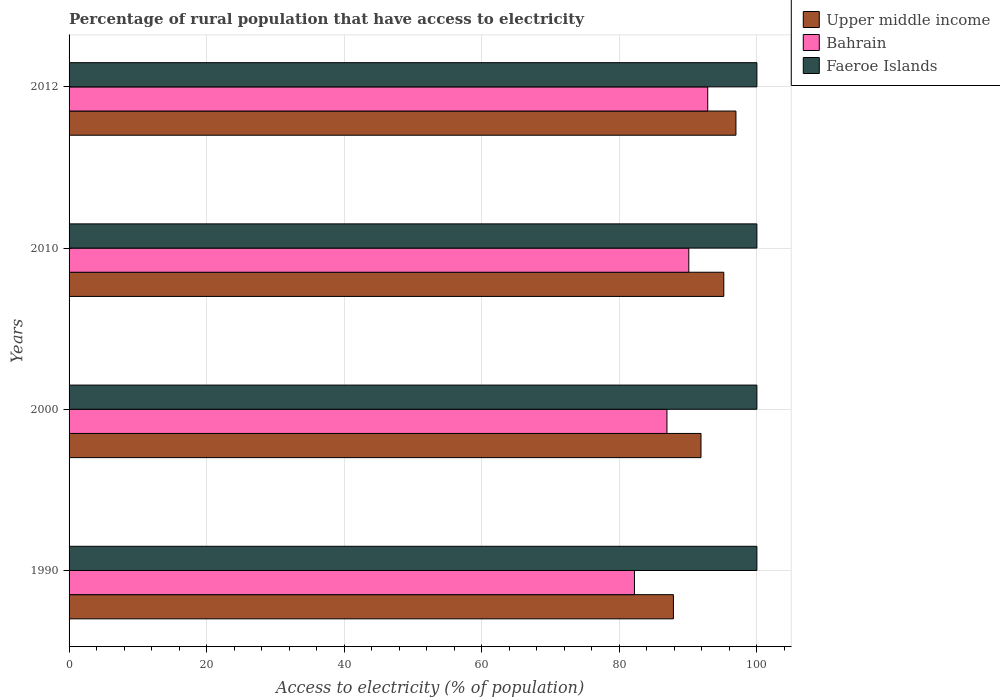How many groups of bars are there?
Your response must be concise. 4. How many bars are there on the 1st tick from the top?
Give a very brief answer. 3. How many bars are there on the 4th tick from the bottom?
Your answer should be very brief. 3. What is the label of the 2nd group of bars from the top?
Your response must be concise. 2010. In how many cases, is the number of bars for a given year not equal to the number of legend labels?
Offer a very short reply. 0. What is the percentage of rural population that have access to electricity in Faeroe Islands in 1990?
Give a very brief answer. 100. Across all years, what is the maximum percentage of rural population that have access to electricity in Upper middle income?
Offer a terse response. 96.95. Across all years, what is the minimum percentage of rural population that have access to electricity in Faeroe Islands?
Your response must be concise. 100. In which year was the percentage of rural population that have access to electricity in Faeroe Islands maximum?
Ensure brevity in your answer.  1990. In which year was the percentage of rural population that have access to electricity in Upper middle income minimum?
Give a very brief answer. 1990. What is the total percentage of rural population that have access to electricity in Upper middle income in the graph?
Give a very brief answer. 371.89. What is the difference between the percentage of rural population that have access to electricity in Faeroe Islands in 2010 and that in 2012?
Provide a succinct answer. 0. What is the difference between the percentage of rural population that have access to electricity in Faeroe Islands in 2010 and the percentage of rural population that have access to electricity in Upper middle income in 2012?
Give a very brief answer. 3.05. What is the average percentage of rural population that have access to electricity in Upper middle income per year?
Provide a short and direct response. 92.97. In the year 2010, what is the difference between the percentage of rural population that have access to electricity in Faeroe Islands and percentage of rural population that have access to electricity in Upper middle income?
Your response must be concise. 4.81. In how many years, is the percentage of rural population that have access to electricity in Upper middle income greater than 76 %?
Ensure brevity in your answer.  4. What is the ratio of the percentage of rural population that have access to electricity in Faeroe Islands in 2000 to that in 2012?
Your answer should be very brief. 1. Is the difference between the percentage of rural population that have access to electricity in Faeroe Islands in 2000 and 2010 greater than the difference between the percentage of rural population that have access to electricity in Upper middle income in 2000 and 2010?
Ensure brevity in your answer.  Yes. What is the difference between the highest and the second highest percentage of rural population that have access to electricity in Bahrain?
Ensure brevity in your answer.  2.75. What is the difference between the highest and the lowest percentage of rural population that have access to electricity in Upper middle income?
Give a very brief answer. 9.09. What does the 1st bar from the top in 2012 represents?
Provide a short and direct response. Faeroe Islands. What does the 1st bar from the bottom in 2012 represents?
Provide a short and direct response. Upper middle income. Is it the case that in every year, the sum of the percentage of rural population that have access to electricity in Upper middle income and percentage of rural population that have access to electricity in Bahrain is greater than the percentage of rural population that have access to electricity in Faeroe Islands?
Your answer should be compact. Yes. What is the difference between two consecutive major ticks on the X-axis?
Offer a terse response. 20. How are the legend labels stacked?
Provide a short and direct response. Vertical. What is the title of the graph?
Offer a very short reply. Percentage of rural population that have access to electricity. Does "Libya" appear as one of the legend labels in the graph?
Your answer should be very brief. No. What is the label or title of the X-axis?
Your response must be concise. Access to electricity (% of population). What is the label or title of the Y-axis?
Provide a succinct answer. Years. What is the Access to electricity (% of population) of Upper middle income in 1990?
Provide a short and direct response. 87.87. What is the Access to electricity (% of population) of Bahrain in 1990?
Offer a terse response. 82.2. What is the Access to electricity (% of population) in Faeroe Islands in 1990?
Your answer should be very brief. 100. What is the Access to electricity (% of population) of Upper middle income in 2000?
Your response must be concise. 91.87. What is the Access to electricity (% of population) of Bahrain in 2000?
Your response must be concise. 86.93. What is the Access to electricity (% of population) of Upper middle income in 2010?
Your answer should be very brief. 95.19. What is the Access to electricity (% of population) of Bahrain in 2010?
Keep it short and to the point. 90.1. What is the Access to electricity (% of population) in Faeroe Islands in 2010?
Ensure brevity in your answer.  100. What is the Access to electricity (% of population) in Upper middle income in 2012?
Your answer should be compact. 96.95. What is the Access to electricity (% of population) of Bahrain in 2012?
Provide a succinct answer. 92.85. What is the Access to electricity (% of population) of Faeroe Islands in 2012?
Your answer should be compact. 100. Across all years, what is the maximum Access to electricity (% of population) of Upper middle income?
Provide a short and direct response. 96.95. Across all years, what is the maximum Access to electricity (% of population) of Bahrain?
Provide a short and direct response. 92.85. Across all years, what is the maximum Access to electricity (% of population) in Faeroe Islands?
Ensure brevity in your answer.  100. Across all years, what is the minimum Access to electricity (% of population) of Upper middle income?
Give a very brief answer. 87.87. Across all years, what is the minimum Access to electricity (% of population) in Bahrain?
Offer a terse response. 82.2. What is the total Access to electricity (% of population) of Upper middle income in the graph?
Give a very brief answer. 371.89. What is the total Access to electricity (% of population) in Bahrain in the graph?
Your answer should be very brief. 352.08. What is the difference between the Access to electricity (% of population) in Upper middle income in 1990 and that in 2000?
Keep it short and to the point. -4.01. What is the difference between the Access to electricity (% of population) of Bahrain in 1990 and that in 2000?
Give a very brief answer. -4.72. What is the difference between the Access to electricity (% of population) of Faeroe Islands in 1990 and that in 2000?
Keep it short and to the point. 0. What is the difference between the Access to electricity (% of population) in Upper middle income in 1990 and that in 2010?
Give a very brief answer. -7.32. What is the difference between the Access to electricity (% of population) of Bahrain in 1990 and that in 2010?
Give a very brief answer. -7.9. What is the difference between the Access to electricity (% of population) of Faeroe Islands in 1990 and that in 2010?
Offer a terse response. 0. What is the difference between the Access to electricity (% of population) in Upper middle income in 1990 and that in 2012?
Ensure brevity in your answer.  -9.09. What is the difference between the Access to electricity (% of population) of Bahrain in 1990 and that in 2012?
Ensure brevity in your answer.  -10.65. What is the difference between the Access to electricity (% of population) in Faeroe Islands in 1990 and that in 2012?
Give a very brief answer. 0. What is the difference between the Access to electricity (% of population) of Upper middle income in 2000 and that in 2010?
Offer a very short reply. -3.32. What is the difference between the Access to electricity (% of population) in Bahrain in 2000 and that in 2010?
Offer a terse response. -3.17. What is the difference between the Access to electricity (% of population) of Upper middle income in 2000 and that in 2012?
Ensure brevity in your answer.  -5.08. What is the difference between the Access to electricity (% of population) in Bahrain in 2000 and that in 2012?
Ensure brevity in your answer.  -5.93. What is the difference between the Access to electricity (% of population) of Faeroe Islands in 2000 and that in 2012?
Your answer should be very brief. 0. What is the difference between the Access to electricity (% of population) in Upper middle income in 2010 and that in 2012?
Provide a short and direct response. -1.76. What is the difference between the Access to electricity (% of population) of Bahrain in 2010 and that in 2012?
Offer a very short reply. -2.75. What is the difference between the Access to electricity (% of population) in Faeroe Islands in 2010 and that in 2012?
Keep it short and to the point. 0. What is the difference between the Access to electricity (% of population) in Upper middle income in 1990 and the Access to electricity (% of population) in Bahrain in 2000?
Your answer should be very brief. 0.94. What is the difference between the Access to electricity (% of population) of Upper middle income in 1990 and the Access to electricity (% of population) of Faeroe Islands in 2000?
Make the answer very short. -12.13. What is the difference between the Access to electricity (% of population) in Bahrain in 1990 and the Access to electricity (% of population) in Faeroe Islands in 2000?
Provide a short and direct response. -17.8. What is the difference between the Access to electricity (% of population) of Upper middle income in 1990 and the Access to electricity (% of population) of Bahrain in 2010?
Offer a very short reply. -2.23. What is the difference between the Access to electricity (% of population) of Upper middle income in 1990 and the Access to electricity (% of population) of Faeroe Islands in 2010?
Your answer should be compact. -12.13. What is the difference between the Access to electricity (% of population) in Bahrain in 1990 and the Access to electricity (% of population) in Faeroe Islands in 2010?
Your answer should be very brief. -17.8. What is the difference between the Access to electricity (% of population) of Upper middle income in 1990 and the Access to electricity (% of population) of Bahrain in 2012?
Provide a succinct answer. -4.99. What is the difference between the Access to electricity (% of population) in Upper middle income in 1990 and the Access to electricity (% of population) in Faeroe Islands in 2012?
Offer a very short reply. -12.13. What is the difference between the Access to electricity (% of population) in Bahrain in 1990 and the Access to electricity (% of population) in Faeroe Islands in 2012?
Your answer should be very brief. -17.8. What is the difference between the Access to electricity (% of population) in Upper middle income in 2000 and the Access to electricity (% of population) in Bahrain in 2010?
Keep it short and to the point. 1.77. What is the difference between the Access to electricity (% of population) in Upper middle income in 2000 and the Access to electricity (% of population) in Faeroe Islands in 2010?
Your response must be concise. -8.13. What is the difference between the Access to electricity (% of population) of Bahrain in 2000 and the Access to electricity (% of population) of Faeroe Islands in 2010?
Keep it short and to the point. -13.07. What is the difference between the Access to electricity (% of population) of Upper middle income in 2000 and the Access to electricity (% of population) of Bahrain in 2012?
Offer a very short reply. -0.98. What is the difference between the Access to electricity (% of population) of Upper middle income in 2000 and the Access to electricity (% of population) of Faeroe Islands in 2012?
Offer a terse response. -8.13. What is the difference between the Access to electricity (% of population) in Bahrain in 2000 and the Access to electricity (% of population) in Faeroe Islands in 2012?
Provide a succinct answer. -13.07. What is the difference between the Access to electricity (% of population) in Upper middle income in 2010 and the Access to electricity (% of population) in Bahrain in 2012?
Your answer should be very brief. 2.34. What is the difference between the Access to electricity (% of population) of Upper middle income in 2010 and the Access to electricity (% of population) of Faeroe Islands in 2012?
Your answer should be compact. -4.81. What is the average Access to electricity (% of population) in Upper middle income per year?
Provide a short and direct response. 92.97. What is the average Access to electricity (% of population) of Bahrain per year?
Keep it short and to the point. 88.02. What is the average Access to electricity (% of population) in Faeroe Islands per year?
Make the answer very short. 100. In the year 1990, what is the difference between the Access to electricity (% of population) of Upper middle income and Access to electricity (% of population) of Bahrain?
Your response must be concise. 5.66. In the year 1990, what is the difference between the Access to electricity (% of population) of Upper middle income and Access to electricity (% of population) of Faeroe Islands?
Give a very brief answer. -12.13. In the year 1990, what is the difference between the Access to electricity (% of population) in Bahrain and Access to electricity (% of population) in Faeroe Islands?
Make the answer very short. -17.8. In the year 2000, what is the difference between the Access to electricity (% of population) in Upper middle income and Access to electricity (% of population) in Bahrain?
Provide a succinct answer. 4.95. In the year 2000, what is the difference between the Access to electricity (% of population) in Upper middle income and Access to electricity (% of population) in Faeroe Islands?
Your response must be concise. -8.13. In the year 2000, what is the difference between the Access to electricity (% of population) in Bahrain and Access to electricity (% of population) in Faeroe Islands?
Make the answer very short. -13.07. In the year 2010, what is the difference between the Access to electricity (% of population) in Upper middle income and Access to electricity (% of population) in Bahrain?
Make the answer very short. 5.09. In the year 2010, what is the difference between the Access to electricity (% of population) in Upper middle income and Access to electricity (% of population) in Faeroe Islands?
Ensure brevity in your answer.  -4.81. In the year 2010, what is the difference between the Access to electricity (% of population) of Bahrain and Access to electricity (% of population) of Faeroe Islands?
Ensure brevity in your answer.  -9.9. In the year 2012, what is the difference between the Access to electricity (% of population) of Upper middle income and Access to electricity (% of population) of Bahrain?
Provide a succinct answer. 4.1. In the year 2012, what is the difference between the Access to electricity (% of population) in Upper middle income and Access to electricity (% of population) in Faeroe Islands?
Your response must be concise. -3.05. In the year 2012, what is the difference between the Access to electricity (% of population) in Bahrain and Access to electricity (% of population) in Faeroe Islands?
Keep it short and to the point. -7.15. What is the ratio of the Access to electricity (% of population) in Upper middle income in 1990 to that in 2000?
Your answer should be very brief. 0.96. What is the ratio of the Access to electricity (% of population) of Bahrain in 1990 to that in 2000?
Keep it short and to the point. 0.95. What is the ratio of the Access to electricity (% of population) of Faeroe Islands in 1990 to that in 2000?
Your answer should be very brief. 1. What is the ratio of the Access to electricity (% of population) of Upper middle income in 1990 to that in 2010?
Your answer should be very brief. 0.92. What is the ratio of the Access to electricity (% of population) of Bahrain in 1990 to that in 2010?
Provide a succinct answer. 0.91. What is the ratio of the Access to electricity (% of population) of Faeroe Islands in 1990 to that in 2010?
Provide a succinct answer. 1. What is the ratio of the Access to electricity (% of population) in Upper middle income in 1990 to that in 2012?
Offer a terse response. 0.91. What is the ratio of the Access to electricity (% of population) of Bahrain in 1990 to that in 2012?
Your answer should be compact. 0.89. What is the ratio of the Access to electricity (% of population) of Upper middle income in 2000 to that in 2010?
Provide a succinct answer. 0.97. What is the ratio of the Access to electricity (% of population) in Bahrain in 2000 to that in 2010?
Your response must be concise. 0.96. What is the ratio of the Access to electricity (% of population) of Upper middle income in 2000 to that in 2012?
Ensure brevity in your answer.  0.95. What is the ratio of the Access to electricity (% of population) in Bahrain in 2000 to that in 2012?
Provide a succinct answer. 0.94. What is the ratio of the Access to electricity (% of population) of Faeroe Islands in 2000 to that in 2012?
Offer a very short reply. 1. What is the ratio of the Access to electricity (% of population) in Upper middle income in 2010 to that in 2012?
Keep it short and to the point. 0.98. What is the ratio of the Access to electricity (% of population) of Bahrain in 2010 to that in 2012?
Your response must be concise. 0.97. What is the ratio of the Access to electricity (% of population) in Faeroe Islands in 2010 to that in 2012?
Make the answer very short. 1. What is the difference between the highest and the second highest Access to electricity (% of population) of Upper middle income?
Ensure brevity in your answer.  1.76. What is the difference between the highest and the second highest Access to electricity (% of population) of Bahrain?
Give a very brief answer. 2.75. What is the difference between the highest and the second highest Access to electricity (% of population) of Faeroe Islands?
Keep it short and to the point. 0. What is the difference between the highest and the lowest Access to electricity (% of population) in Upper middle income?
Offer a very short reply. 9.09. What is the difference between the highest and the lowest Access to electricity (% of population) of Bahrain?
Offer a terse response. 10.65. 